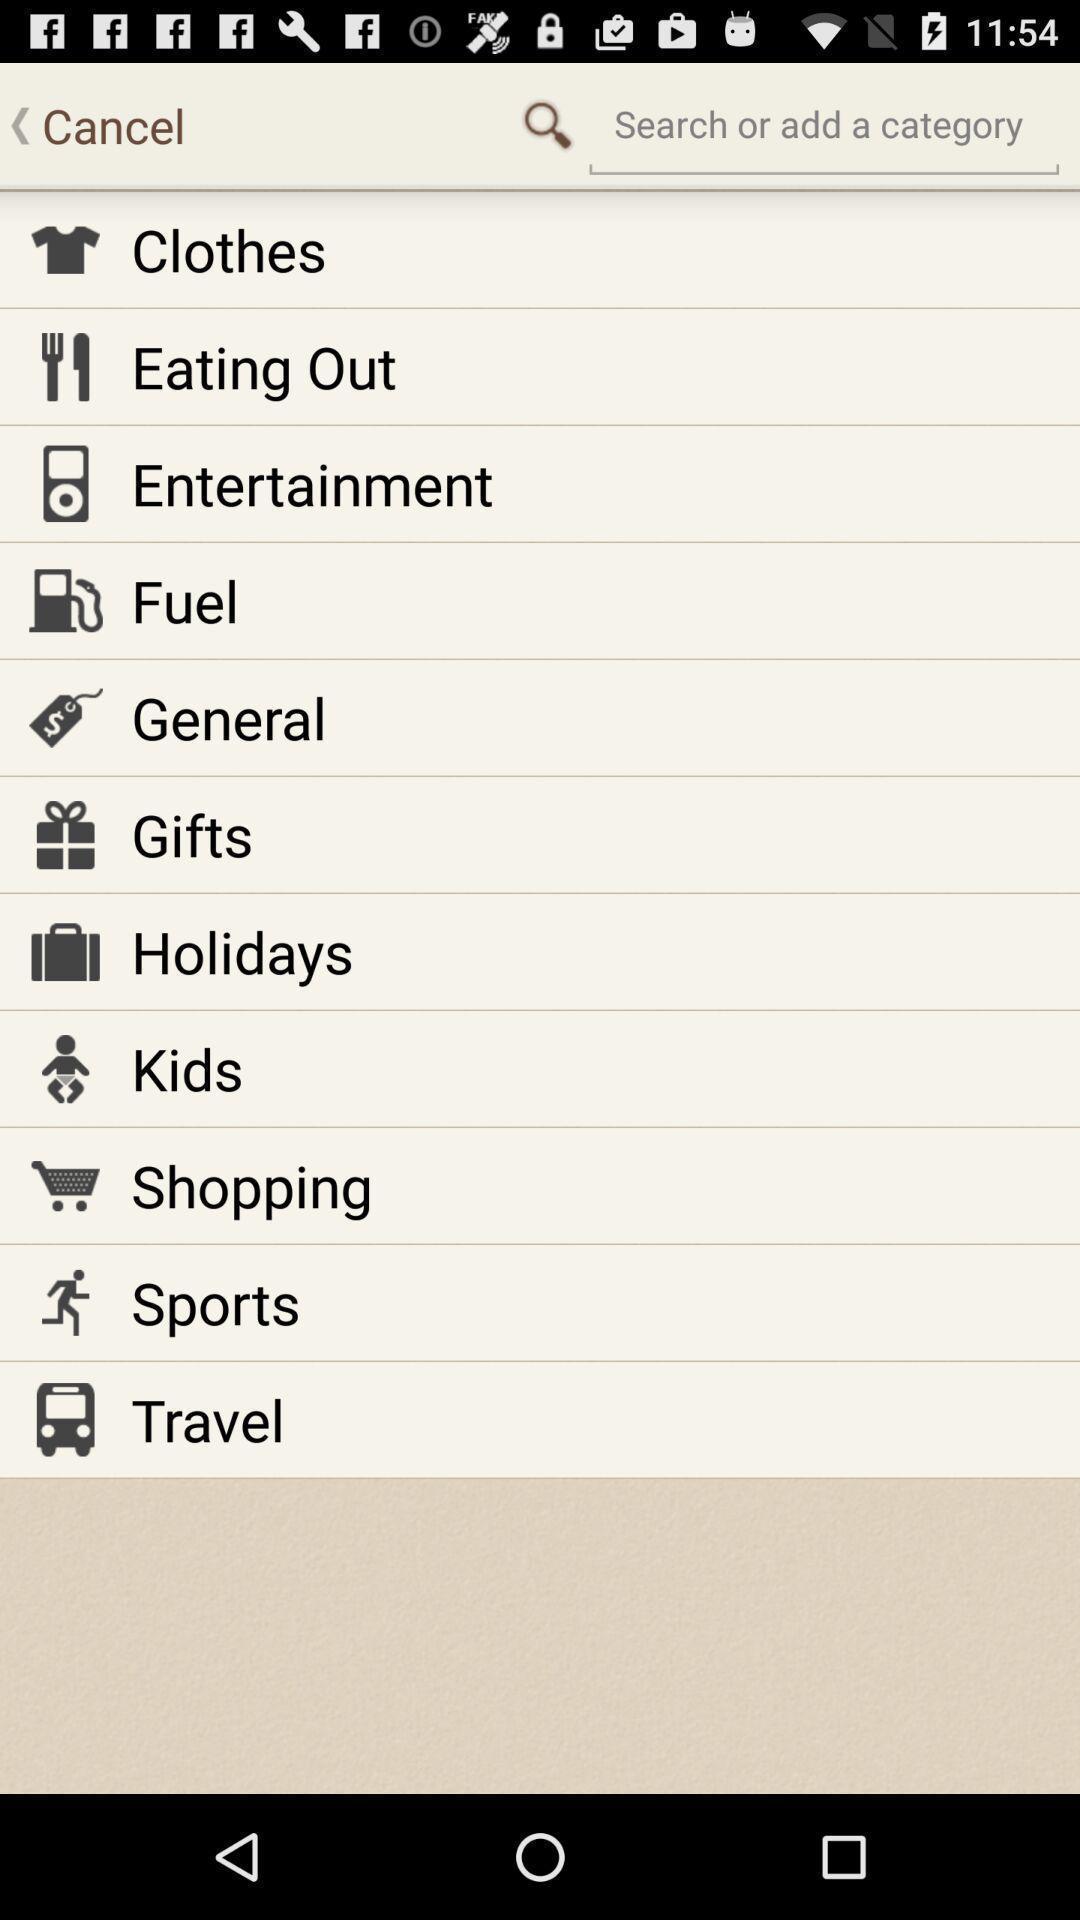Please provide a description for this image. Page showing list of options in a budget app. 